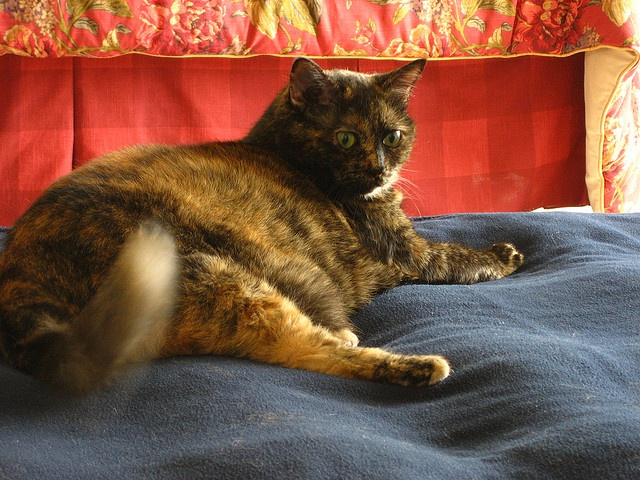Describe the objects in this image and their specific colors. I can see cat in tan, black, maroon, and olive tones and bed in tan, gray, and black tones in this image. 